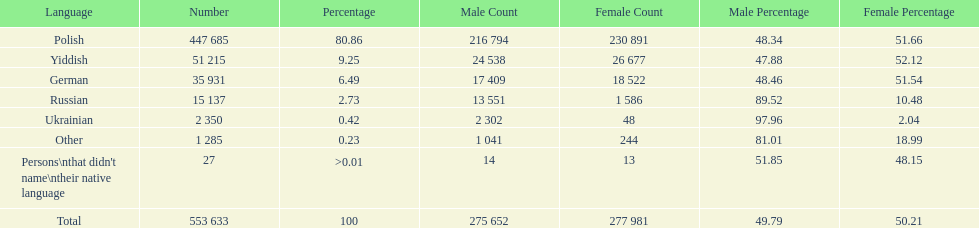Which language did the most people in the imperial census of 1897 speak in the p&#322;ock governorate? Polish. 